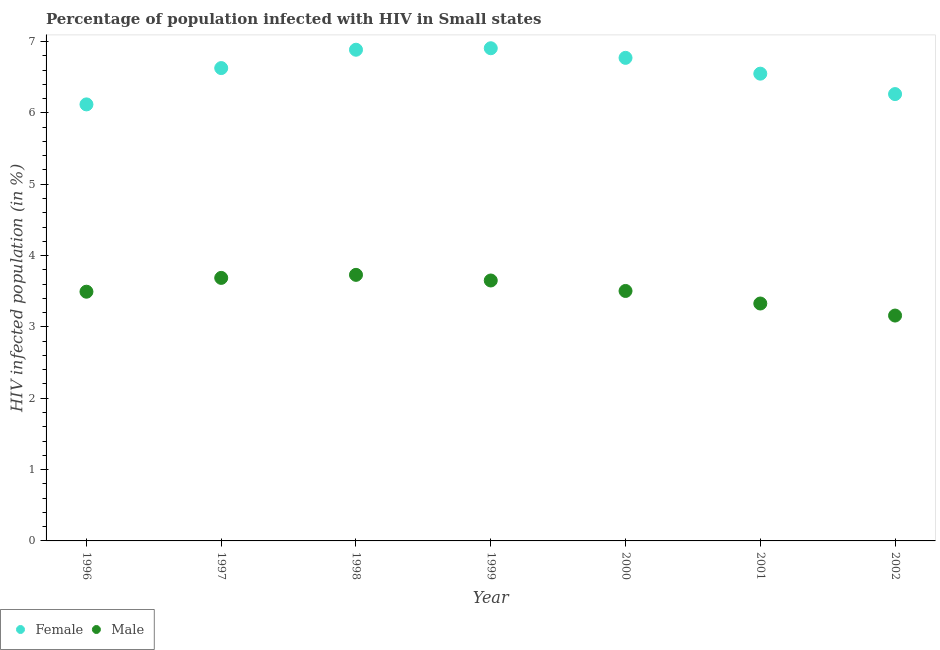Is the number of dotlines equal to the number of legend labels?
Your answer should be compact. Yes. What is the percentage of females who are infected with hiv in 1998?
Offer a terse response. 6.89. Across all years, what is the maximum percentage of males who are infected with hiv?
Your answer should be compact. 3.73. Across all years, what is the minimum percentage of males who are infected with hiv?
Offer a terse response. 3.16. In which year was the percentage of females who are infected with hiv maximum?
Keep it short and to the point. 1999. In which year was the percentage of females who are infected with hiv minimum?
Provide a short and direct response. 1996. What is the total percentage of males who are infected with hiv in the graph?
Your answer should be very brief. 24.55. What is the difference between the percentage of males who are infected with hiv in 1999 and that in 2000?
Provide a succinct answer. 0.15. What is the difference between the percentage of males who are infected with hiv in 2002 and the percentage of females who are infected with hiv in 1998?
Your response must be concise. -3.73. What is the average percentage of males who are infected with hiv per year?
Keep it short and to the point. 3.51. In the year 1999, what is the difference between the percentage of females who are infected with hiv and percentage of males who are infected with hiv?
Make the answer very short. 3.26. What is the ratio of the percentage of females who are infected with hiv in 2001 to that in 2002?
Your answer should be compact. 1.05. Is the percentage of females who are infected with hiv in 1998 less than that in 2000?
Give a very brief answer. No. What is the difference between the highest and the second highest percentage of females who are infected with hiv?
Provide a succinct answer. 0.02. What is the difference between the highest and the lowest percentage of males who are infected with hiv?
Make the answer very short. 0.57. In how many years, is the percentage of males who are infected with hiv greater than the average percentage of males who are infected with hiv taken over all years?
Your answer should be compact. 3. Is the sum of the percentage of males who are infected with hiv in 1997 and 1999 greater than the maximum percentage of females who are infected with hiv across all years?
Your response must be concise. Yes. Does the percentage of females who are infected with hiv monotonically increase over the years?
Provide a succinct answer. No. Is the percentage of females who are infected with hiv strictly greater than the percentage of males who are infected with hiv over the years?
Keep it short and to the point. Yes. How many dotlines are there?
Provide a succinct answer. 2. What is the difference between two consecutive major ticks on the Y-axis?
Offer a terse response. 1. Are the values on the major ticks of Y-axis written in scientific E-notation?
Provide a short and direct response. No. How many legend labels are there?
Provide a short and direct response. 2. What is the title of the graph?
Offer a terse response. Percentage of population infected with HIV in Small states. Does "Unregistered firms" appear as one of the legend labels in the graph?
Provide a short and direct response. No. What is the label or title of the Y-axis?
Make the answer very short. HIV infected population (in %). What is the HIV infected population (in %) of Female in 1996?
Give a very brief answer. 6.12. What is the HIV infected population (in %) in Male in 1996?
Keep it short and to the point. 3.49. What is the HIV infected population (in %) in Female in 1997?
Make the answer very short. 6.63. What is the HIV infected population (in %) in Male in 1997?
Your answer should be compact. 3.69. What is the HIV infected population (in %) of Female in 1998?
Give a very brief answer. 6.89. What is the HIV infected population (in %) of Male in 1998?
Offer a terse response. 3.73. What is the HIV infected population (in %) of Female in 1999?
Offer a terse response. 6.91. What is the HIV infected population (in %) in Male in 1999?
Provide a succinct answer. 3.65. What is the HIV infected population (in %) of Female in 2000?
Give a very brief answer. 6.77. What is the HIV infected population (in %) of Male in 2000?
Keep it short and to the point. 3.5. What is the HIV infected population (in %) in Female in 2001?
Your answer should be compact. 6.55. What is the HIV infected population (in %) in Male in 2001?
Offer a terse response. 3.33. What is the HIV infected population (in %) in Female in 2002?
Your answer should be very brief. 6.26. What is the HIV infected population (in %) of Male in 2002?
Provide a succinct answer. 3.16. Across all years, what is the maximum HIV infected population (in %) in Female?
Provide a succinct answer. 6.91. Across all years, what is the maximum HIV infected population (in %) of Male?
Provide a succinct answer. 3.73. Across all years, what is the minimum HIV infected population (in %) in Female?
Give a very brief answer. 6.12. Across all years, what is the minimum HIV infected population (in %) in Male?
Offer a terse response. 3.16. What is the total HIV infected population (in %) in Female in the graph?
Provide a short and direct response. 46.12. What is the total HIV infected population (in %) in Male in the graph?
Give a very brief answer. 24.55. What is the difference between the HIV infected population (in %) in Female in 1996 and that in 1997?
Provide a succinct answer. -0.51. What is the difference between the HIV infected population (in %) in Male in 1996 and that in 1997?
Your response must be concise. -0.19. What is the difference between the HIV infected population (in %) in Female in 1996 and that in 1998?
Provide a succinct answer. -0.77. What is the difference between the HIV infected population (in %) in Male in 1996 and that in 1998?
Your answer should be very brief. -0.24. What is the difference between the HIV infected population (in %) in Female in 1996 and that in 1999?
Give a very brief answer. -0.79. What is the difference between the HIV infected population (in %) of Male in 1996 and that in 1999?
Provide a succinct answer. -0.16. What is the difference between the HIV infected population (in %) of Female in 1996 and that in 2000?
Your answer should be compact. -0.65. What is the difference between the HIV infected population (in %) of Male in 1996 and that in 2000?
Ensure brevity in your answer.  -0.01. What is the difference between the HIV infected population (in %) in Female in 1996 and that in 2001?
Keep it short and to the point. -0.43. What is the difference between the HIV infected population (in %) in Male in 1996 and that in 2001?
Your response must be concise. 0.17. What is the difference between the HIV infected population (in %) of Female in 1996 and that in 2002?
Make the answer very short. -0.14. What is the difference between the HIV infected population (in %) in Male in 1996 and that in 2002?
Ensure brevity in your answer.  0.33. What is the difference between the HIV infected population (in %) in Female in 1997 and that in 1998?
Keep it short and to the point. -0.26. What is the difference between the HIV infected population (in %) in Male in 1997 and that in 1998?
Give a very brief answer. -0.04. What is the difference between the HIV infected population (in %) of Female in 1997 and that in 1999?
Offer a terse response. -0.28. What is the difference between the HIV infected population (in %) in Male in 1997 and that in 1999?
Keep it short and to the point. 0.04. What is the difference between the HIV infected population (in %) of Female in 1997 and that in 2000?
Your answer should be very brief. -0.14. What is the difference between the HIV infected population (in %) in Male in 1997 and that in 2000?
Keep it short and to the point. 0.18. What is the difference between the HIV infected population (in %) of Female in 1997 and that in 2001?
Give a very brief answer. 0.08. What is the difference between the HIV infected population (in %) of Male in 1997 and that in 2001?
Your answer should be compact. 0.36. What is the difference between the HIV infected population (in %) of Female in 1997 and that in 2002?
Your answer should be very brief. 0.36. What is the difference between the HIV infected population (in %) of Male in 1997 and that in 2002?
Give a very brief answer. 0.53. What is the difference between the HIV infected population (in %) in Female in 1998 and that in 1999?
Your answer should be very brief. -0.02. What is the difference between the HIV infected population (in %) in Male in 1998 and that in 1999?
Provide a short and direct response. 0.08. What is the difference between the HIV infected population (in %) in Female in 1998 and that in 2000?
Offer a very short reply. 0.11. What is the difference between the HIV infected population (in %) in Male in 1998 and that in 2000?
Make the answer very short. 0.23. What is the difference between the HIV infected population (in %) in Female in 1998 and that in 2001?
Keep it short and to the point. 0.34. What is the difference between the HIV infected population (in %) in Male in 1998 and that in 2001?
Provide a short and direct response. 0.4. What is the difference between the HIV infected population (in %) in Female in 1998 and that in 2002?
Make the answer very short. 0.62. What is the difference between the HIV infected population (in %) of Male in 1998 and that in 2002?
Your response must be concise. 0.57. What is the difference between the HIV infected population (in %) in Female in 1999 and that in 2000?
Your answer should be compact. 0.13. What is the difference between the HIV infected population (in %) of Male in 1999 and that in 2000?
Provide a succinct answer. 0.15. What is the difference between the HIV infected population (in %) of Female in 1999 and that in 2001?
Your answer should be very brief. 0.36. What is the difference between the HIV infected population (in %) in Male in 1999 and that in 2001?
Provide a succinct answer. 0.32. What is the difference between the HIV infected population (in %) in Female in 1999 and that in 2002?
Your response must be concise. 0.64. What is the difference between the HIV infected population (in %) in Male in 1999 and that in 2002?
Keep it short and to the point. 0.49. What is the difference between the HIV infected population (in %) in Female in 2000 and that in 2001?
Your response must be concise. 0.22. What is the difference between the HIV infected population (in %) in Male in 2000 and that in 2001?
Make the answer very short. 0.18. What is the difference between the HIV infected population (in %) of Female in 2000 and that in 2002?
Provide a short and direct response. 0.51. What is the difference between the HIV infected population (in %) in Male in 2000 and that in 2002?
Provide a succinct answer. 0.34. What is the difference between the HIV infected population (in %) in Female in 2001 and that in 2002?
Provide a succinct answer. 0.29. What is the difference between the HIV infected population (in %) of Male in 2001 and that in 2002?
Offer a terse response. 0.17. What is the difference between the HIV infected population (in %) of Female in 1996 and the HIV infected population (in %) of Male in 1997?
Give a very brief answer. 2.43. What is the difference between the HIV infected population (in %) of Female in 1996 and the HIV infected population (in %) of Male in 1998?
Offer a terse response. 2.39. What is the difference between the HIV infected population (in %) in Female in 1996 and the HIV infected population (in %) in Male in 1999?
Provide a short and direct response. 2.47. What is the difference between the HIV infected population (in %) in Female in 1996 and the HIV infected population (in %) in Male in 2000?
Offer a terse response. 2.62. What is the difference between the HIV infected population (in %) in Female in 1996 and the HIV infected population (in %) in Male in 2001?
Keep it short and to the point. 2.79. What is the difference between the HIV infected population (in %) in Female in 1996 and the HIV infected population (in %) in Male in 2002?
Ensure brevity in your answer.  2.96. What is the difference between the HIV infected population (in %) in Female in 1997 and the HIV infected population (in %) in Male in 1998?
Offer a very short reply. 2.9. What is the difference between the HIV infected population (in %) of Female in 1997 and the HIV infected population (in %) of Male in 1999?
Keep it short and to the point. 2.98. What is the difference between the HIV infected population (in %) of Female in 1997 and the HIV infected population (in %) of Male in 2000?
Your response must be concise. 3.12. What is the difference between the HIV infected population (in %) of Female in 1997 and the HIV infected population (in %) of Male in 2001?
Offer a terse response. 3.3. What is the difference between the HIV infected population (in %) in Female in 1997 and the HIV infected population (in %) in Male in 2002?
Keep it short and to the point. 3.47. What is the difference between the HIV infected population (in %) in Female in 1998 and the HIV infected population (in %) in Male in 1999?
Your answer should be very brief. 3.23. What is the difference between the HIV infected population (in %) of Female in 1998 and the HIV infected population (in %) of Male in 2000?
Ensure brevity in your answer.  3.38. What is the difference between the HIV infected population (in %) of Female in 1998 and the HIV infected population (in %) of Male in 2001?
Provide a succinct answer. 3.56. What is the difference between the HIV infected population (in %) of Female in 1998 and the HIV infected population (in %) of Male in 2002?
Ensure brevity in your answer.  3.73. What is the difference between the HIV infected population (in %) in Female in 1999 and the HIV infected population (in %) in Male in 2000?
Give a very brief answer. 3.4. What is the difference between the HIV infected population (in %) in Female in 1999 and the HIV infected population (in %) in Male in 2001?
Provide a short and direct response. 3.58. What is the difference between the HIV infected population (in %) of Female in 1999 and the HIV infected population (in %) of Male in 2002?
Make the answer very short. 3.75. What is the difference between the HIV infected population (in %) in Female in 2000 and the HIV infected population (in %) in Male in 2001?
Provide a short and direct response. 3.44. What is the difference between the HIV infected population (in %) of Female in 2000 and the HIV infected population (in %) of Male in 2002?
Make the answer very short. 3.61. What is the difference between the HIV infected population (in %) in Female in 2001 and the HIV infected population (in %) in Male in 2002?
Ensure brevity in your answer.  3.39. What is the average HIV infected population (in %) of Female per year?
Your answer should be very brief. 6.59. What is the average HIV infected population (in %) in Male per year?
Your response must be concise. 3.51. In the year 1996, what is the difference between the HIV infected population (in %) of Female and HIV infected population (in %) of Male?
Make the answer very short. 2.63. In the year 1997, what is the difference between the HIV infected population (in %) of Female and HIV infected population (in %) of Male?
Provide a succinct answer. 2.94. In the year 1998, what is the difference between the HIV infected population (in %) in Female and HIV infected population (in %) in Male?
Make the answer very short. 3.16. In the year 1999, what is the difference between the HIV infected population (in %) in Female and HIV infected population (in %) in Male?
Give a very brief answer. 3.26. In the year 2000, what is the difference between the HIV infected population (in %) in Female and HIV infected population (in %) in Male?
Ensure brevity in your answer.  3.27. In the year 2001, what is the difference between the HIV infected population (in %) in Female and HIV infected population (in %) in Male?
Your answer should be very brief. 3.22. In the year 2002, what is the difference between the HIV infected population (in %) in Female and HIV infected population (in %) in Male?
Provide a short and direct response. 3.1. What is the ratio of the HIV infected population (in %) in Female in 1996 to that in 1997?
Keep it short and to the point. 0.92. What is the ratio of the HIV infected population (in %) of Male in 1996 to that in 1997?
Your answer should be compact. 0.95. What is the ratio of the HIV infected population (in %) in Female in 1996 to that in 1998?
Your answer should be very brief. 0.89. What is the ratio of the HIV infected population (in %) of Male in 1996 to that in 1998?
Offer a terse response. 0.94. What is the ratio of the HIV infected population (in %) of Female in 1996 to that in 1999?
Make the answer very short. 0.89. What is the ratio of the HIV infected population (in %) in Female in 1996 to that in 2000?
Offer a terse response. 0.9. What is the ratio of the HIV infected population (in %) in Male in 1996 to that in 2000?
Offer a terse response. 1. What is the ratio of the HIV infected population (in %) in Female in 1996 to that in 2001?
Make the answer very short. 0.93. What is the ratio of the HIV infected population (in %) of Male in 1996 to that in 2001?
Give a very brief answer. 1.05. What is the ratio of the HIV infected population (in %) of Female in 1996 to that in 2002?
Your response must be concise. 0.98. What is the ratio of the HIV infected population (in %) of Male in 1996 to that in 2002?
Offer a very short reply. 1.11. What is the ratio of the HIV infected population (in %) of Female in 1997 to that in 1998?
Give a very brief answer. 0.96. What is the ratio of the HIV infected population (in %) of Female in 1997 to that in 1999?
Make the answer very short. 0.96. What is the ratio of the HIV infected population (in %) in Female in 1997 to that in 2000?
Your answer should be very brief. 0.98. What is the ratio of the HIV infected population (in %) of Male in 1997 to that in 2000?
Offer a terse response. 1.05. What is the ratio of the HIV infected population (in %) of Male in 1997 to that in 2001?
Make the answer very short. 1.11. What is the ratio of the HIV infected population (in %) in Female in 1997 to that in 2002?
Your answer should be compact. 1.06. What is the ratio of the HIV infected population (in %) of Male in 1997 to that in 2002?
Provide a succinct answer. 1.17. What is the ratio of the HIV infected population (in %) in Female in 1998 to that in 1999?
Your answer should be very brief. 1. What is the ratio of the HIV infected population (in %) of Male in 1998 to that in 1999?
Offer a terse response. 1.02. What is the ratio of the HIV infected population (in %) of Female in 1998 to that in 2000?
Your answer should be compact. 1.02. What is the ratio of the HIV infected population (in %) of Male in 1998 to that in 2000?
Provide a succinct answer. 1.06. What is the ratio of the HIV infected population (in %) of Female in 1998 to that in 2001?
Provide a succinct answer. 1.05. What is the ratio of the HIV infected population (in %) in Male in 1998 to that in 2001?
Keep it short and to the point. 1.12. What is the ratio of the HIV infected population (in %) of Female in 1998 to that in 2002?
Make the answer very short. 1.1. What is the ratio of the HIV infected population (in %) of Male in 1998 to that in 2002?
Your answer should be very brief. 1.18. What is the ratio of the HIV infected population (in %) of Female in 1999 to that in 2000?
Make the answer very short. 1.02. What is the ratio of the HIV infected population (in %) of Male in 1999 to that in 2000?
Your response must be concise. 1.04. What is the ratio of the HIV infected population (in %) in Female in 1999 to that in 2001?
Your answer should be compact. 1.05. What is the ratio of the HIV infected population (in %) in Male in 1999 to that in 2001?
Give a very brief answer. 1.1. What is the ratio of the HIV infected population (in %) of Female in 1999 to that in 2002?
Give a very brief answer. 1.1. What is the ratio of the HIV infected population (in %) of Male in 1999 to that in 2002?
Provide a succinct answer. 1.16. What is the ratio of the HIV infected population (in %) of Female in 2000 to that in 2001?
Give a very brief answer. 1.03. What is the ratio of the HIV infected population (in %) of Male in 2000 to that in 2001?
Ensure brevity in your answer.  1.05. What is the ratio of the HIV infected population (in %) of Female in 2000 to that in 2002?
Your answer should be compact. 1.08. What is the ratio of the HIV infected population (in %) in Male in 2000 to that in 2002?
Your answer should be very brief. 1.11. What is the ratio of the HIV infected population (in %) of Female in 2001 to that in 2002?
Your answer should be compact. 1.05. What is the ratio of the HIV infected population (in %) in Male in 2001 to that in 2002?
Offer a terse response. 1.05. What is the difference between the highest and the second highest HIV infected population (in %) in Female?
Offer a terse response. 0.02. What is the difference between the highest and the second highest HIV infected population (in %) in Male?
Ensure brevity in your answer.  0.04. What is the difference between the highest and the lowest HIV infected population (in %) of Female?
Provide a short and direct response. 0.79. What is the difference between the highest and the lowest HIV infected population (in %) in Male?
Your answer should be very brief. 0.57. 